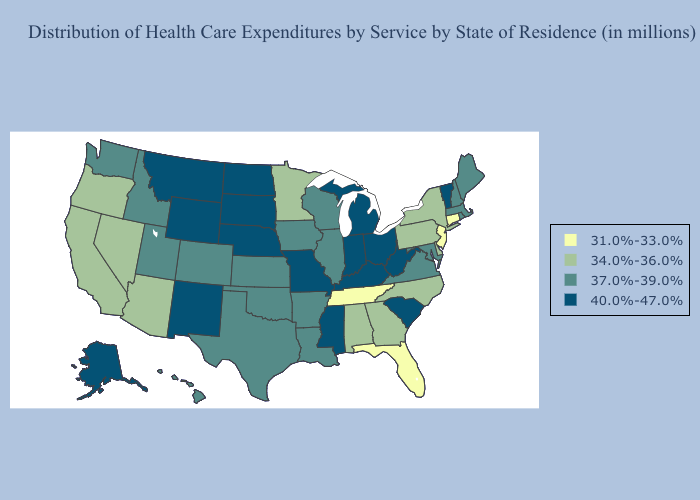What is the value of Alabama?
Be succinct. 34.0%-36.0%. What is the lowest value in states that border Idaho?
Write a very short answer. 34.0%-36.0%. Which states have the highest value in the USA?
Answer briefly. Alaska, Indiana, Kentucky, Michigan, Mississippi, Missouri, Montana, Nebraska, New Mexico, North Dakota, Ohio, South Carolina, South Dakota, Vermont, West Virginia, Wyoming. What is the highest value in the South ?
Be succinct. 40.0%-47.0%. Does the first symbol in the legend represent the smallest category?
Write a very short answer. Yes. What is the highest value in states that border Rhode Island?
Quick response, please. 37.0%-39.0%. Among the states that border Nebraska , does Iowa have the highest value?
Write a very short answer. No. Among the states that border Ohio , which have the lowest value?
Answer briefly. Pennsylvania. Among the states that border Arizona , does New Mexico have the highest value?
Give a very brief answer. Yes. Which states have the lowest value in the USA?
Quick response, please. Connecticut, Florida, New Jersey, Tennessee. What is the value of Virginia?
Keep it brief. 37.0%-39.0%. What is the value of Washington?
Short answer required. 37.0%-39.0%. Does Maryland have a lower value than Ohio?
Write a very short answer. Yes. How many symbols are there in the legend?
Write a very short answer. 4. 